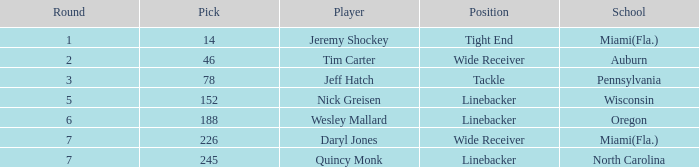Could you help me parse every detail presented in this table? {'header': ['Round', 'Pick', 'Player', 'Position', 'School'], 'rows': [['1', '14', 'Jeremy Shockey', 'Tight End', 'Miami(Fla.)'], ['2', '46', 'Tim Carter', 'Wide Receiver', 'Auburn'], ['3', '78', 'Jeff Hatch', 'Tackle', 'Pennsylvania'], ['5', '152', 'Nick Greisen', 'Linebacker', 'Wisconsin'], ['6', '188', 'Wesley Mallard', 'Linebacker', 'Oregon'], ['7', '226', 'Daryl Jones', 'Wide Receiver', 'Miami(Fla.)'], ['7', '245', 'Quincy Monk', 'Linebacker', 'North Carolina']]} Which educational institution did the player in round 3 get drafted from? Pennsylvania. 